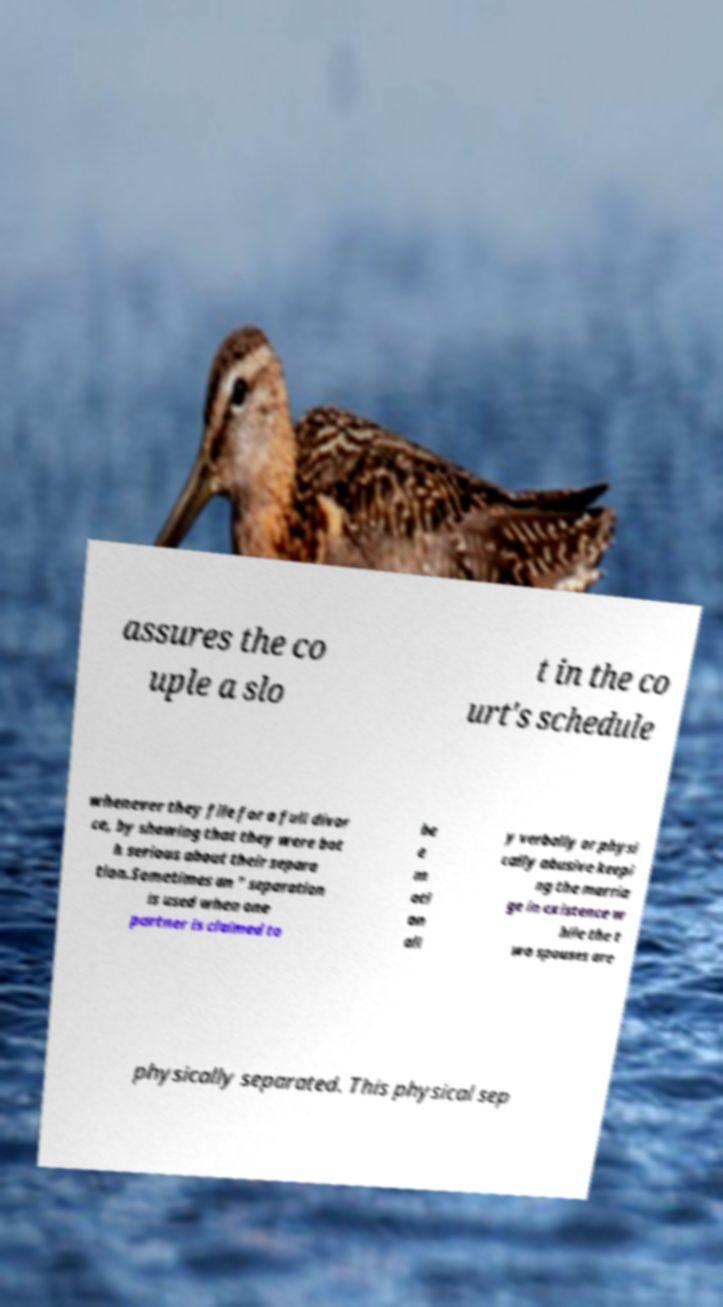Could you extract and type out the text from this image? assures the co uple a slo t in the co urt's schedule whenever they file for a full divor ce, by showing that they were bot h serious about their separa tion.Sometimes an " separation is used when one partner is claimed to be e m oti on all y verbally or physi cally abusive keepi ng the marria ge in existence w hile the t wo spouses are physically separated. This physical sep 